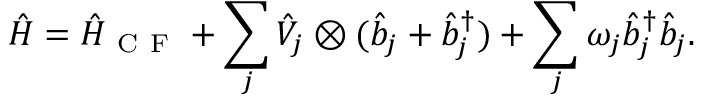<formula> <loc_0><loc_0><loc_500><loc_500>\hat { H } = \hat { H } _ { C F } + \sum _ { j } \hat { V } _ { j } \otimes ( \hat { b } _ { j } + \hat { b } _ { j } ^ { \dagger } ) + \sum _ { j } \omega _ { j } \hat { b } _ { j } ^ { \dagger } \hat { b } _ { j } .</formula> 